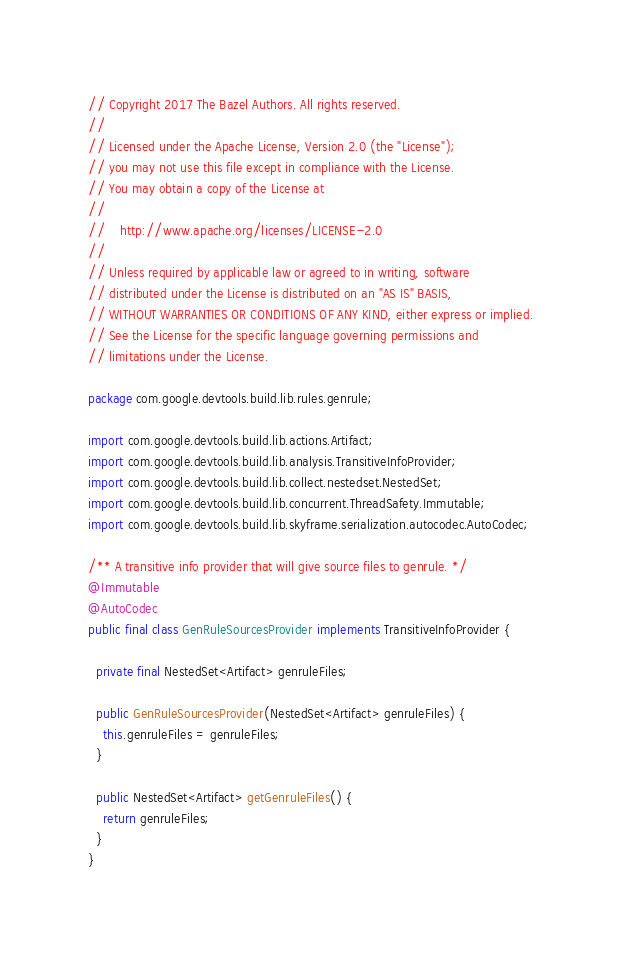Convert code to text. <code><loc_0><loc_0><loc_500><loc_500><_Java_>// Copyright 2017 The Bazel Authors. All rights reserved.
//
// Licensed under the Apache License, Version 2.0 (the "License");
// you may not use this file except in compliance with the License.
// You may obtain a copy of the License at
//
//    http://www.apache.org/licenses/LICENSE-2.0
//
// Unless required by applicable law or agreed to in writing, software
// distributed under the License is distributed on an "AS IS" BASIS,
// WITHOUT WARRANTIES OR CONDITIONS OF ANY KIND, either express or implied.
// See the License for the specific language governing permissions and
// limitations under the License.

package com.google.devtools.build.lib.rules.genrule;

import com.google.devtools.build.lib.actions.Artifact;
import com.google.devtools.build.lib.analysis.TransitiveInfoProvider;
import com.google.devtools.build.lib.collect.nestedset.NestedSet;
import com.google.devtools.build.lib.concurrent.ThreadSafety.Immutable;
import com.google.devtools.build.lib.skyframe.serialization.autocodec.AutoCodec;

/** A transitive info provider that will give source files to genrule. */
@Immutable
@AutoCodec
public final class GenRuleSourcesProvider implements TransitiveInfoProvider {

  private final NestedSet<Artifact> genruleFiles;

  public GenRuleSourcesProvider(NestedSet<Artifact> genruleFiles) {
    this.genruleFiles = genruleFiles;
  }

  public NestedSet<Artifact> getGenruleFiles() {
    return genruleFiles;
  }
}
</code> 